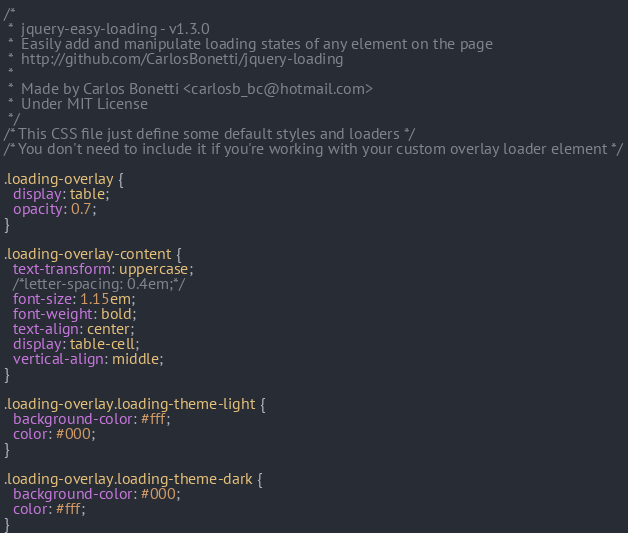<code> <loc_0><loc_0><loc_500><loc_500><_CSS_>/*
 *  jquery-easy-loading - v1.3.0
 *  Easily add and manipulate loading states of any element on the page
 *  http://github.com/CarlosBonetti/jquery-loading
 *
 *  Made by Carlos Bonetti <carlosb_bc@hotmail.com>
 *  Under MIT License
 */
/* This CSS file just define some default styles and loaders */
/* You don't need to include it if you're working with your custom overlay loader element */

.loading-overlay {
  display: table;
  opacity: 0.7;
}

.loading-overlay-content {
  text-transform: uppercase;
  /*letter-spacing: 0.4em;*/
  font-size: 1.15em;
  font-weight: bold;
  text-align: center;
  display: table-cell;
  vertical-align: middle;
}

.loading-overlay.loading-theme-light {
  background-color: #fff;
  color: #000;
}

.loading-overlay.loading-theme-dark {
  background-color: #000;
  color: #fff;
}
</code> 